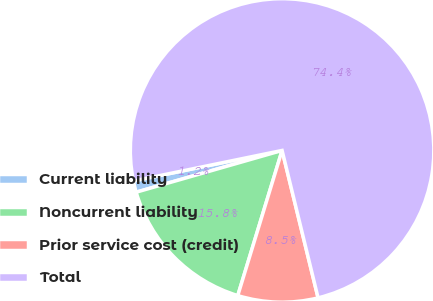<chart> <loc_0><loc_0><loc_500><loc_500><pie_chart><fcel>Current liability<fcel>Noncurrent liability<fcel>Prior service cost (credit)<fcel>Total<nl><fcel>1.21%<fcel>15.85%<fcel>8.53%<fcel>74.42%<nl></chart> 